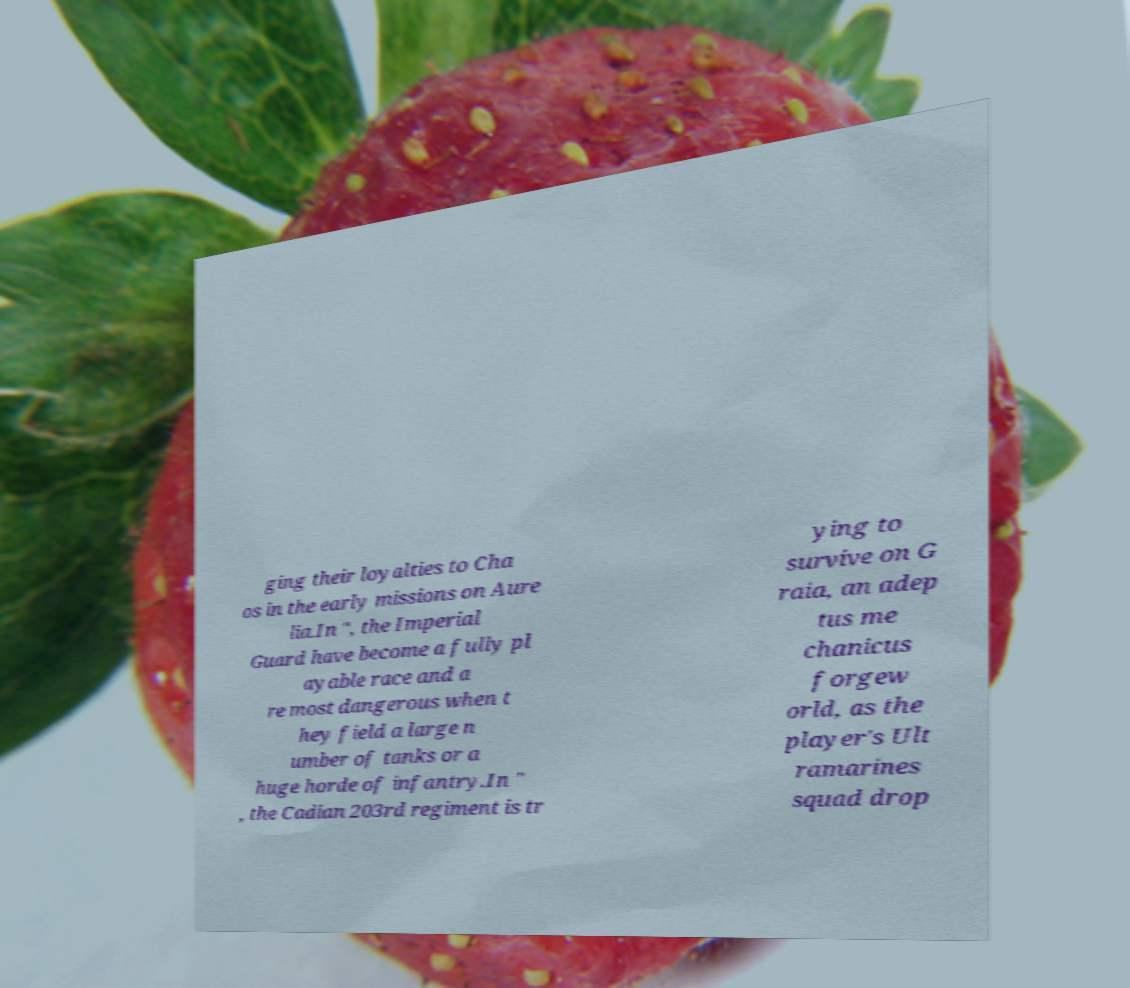Please read and relay the text visible in this image. What does it say? ging their loyalties to Cha os in the early missions on Aure lia.In ", the Imperial Guard have become a fully pl ayable race and a re most dangerous when t hey field a large n umber of tanks or a huge horde of infantry.In " , the Cadian 203rd regiment is tr ying to survive on G raia, an adep tus me chanicus forgew orld, as the player's Ult ramarines squad drop 